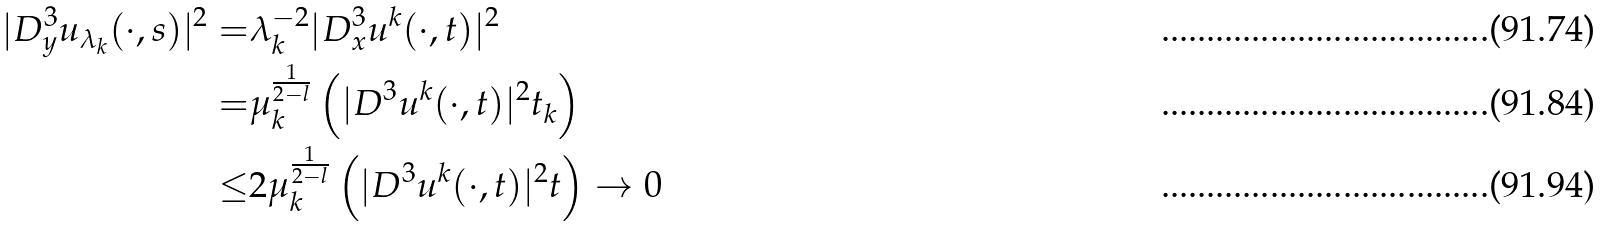Convert formula to latex. <formula><loc_0><loc_0><loc_500><loc_500>| D ^ { 3 } _ { y } u _ { \lambda _ { k } } ( \cdot , s ) | ^ { 2 } = & \lambda _ { k } ^ { - 2 } | D ^ { 3 } _ { x } u ^ { k } ( \cdot , t ) | ^ { 2 } \\ = & \mu _ { k } ^ { \frac { 1 } { 2 - l } } \left ( | D ^ { 3 } u ^ { k } ( \cdot , t ) | ^ { 2 } t _ { k } \right ) \\ \leq & 2 \mu _ { k } ^ { \frac { 1 } { 2 - l } } \left ( | D ^ { 3 } u ^ { k } ( \cdot , t ) | ^ { 2 } t \right ) \rightarrow 0</formula> 